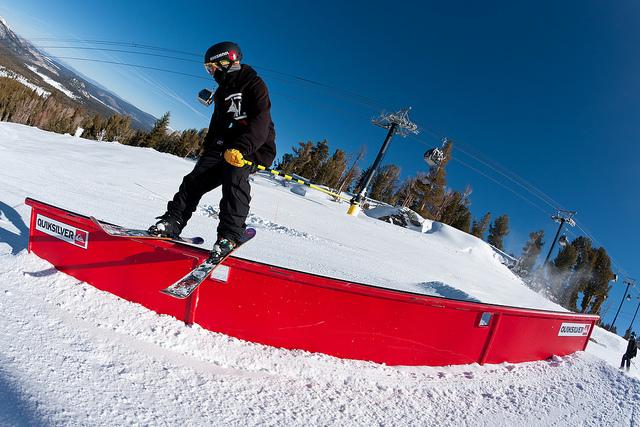What is the snowboarder on?
Short answer required. Rail. Is there a ski lift in the photo?
Answer briefly. Yes. What sport is this?
Give a very brief answer. Skiing. 